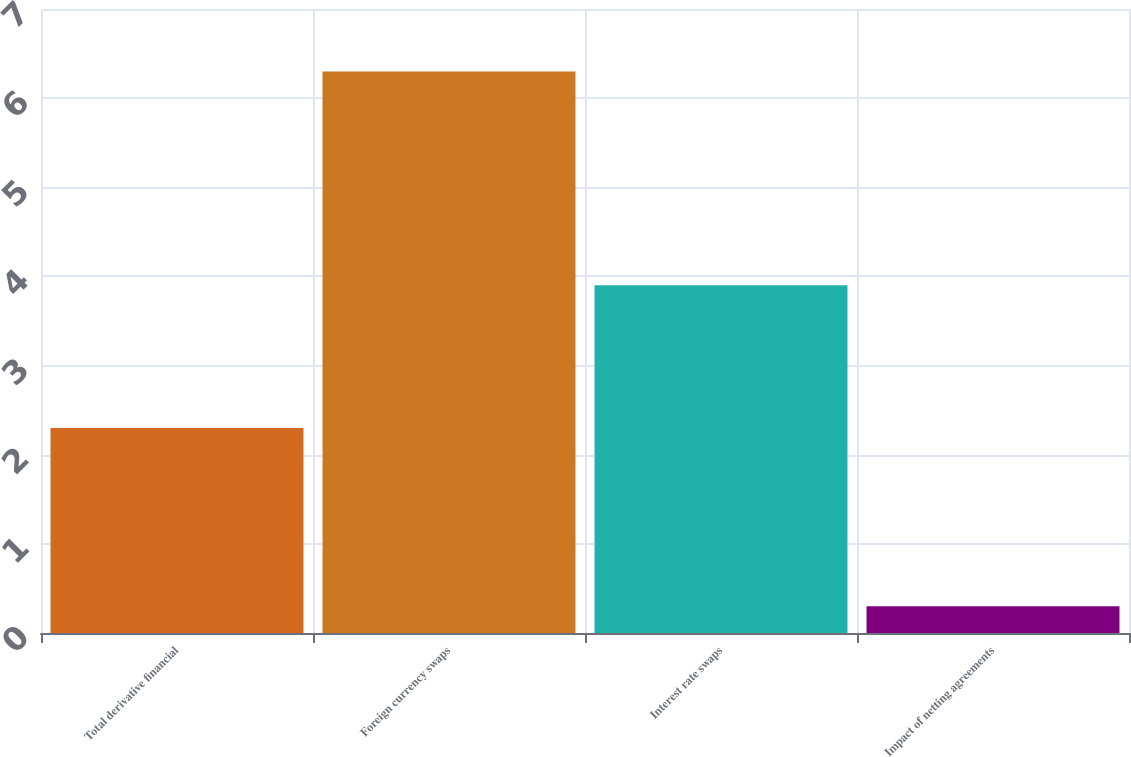<chart> <loc_0><loc_0><loc_500><loc_500><bar_chart><fcel>Total derivative financial<fcel>Foreign currency swaps<fcel>Interest rate swaps<fcel>Impact of netting agreements<nl><fcel>2.3<fcel>6.3<fcel>3.9<fcel>0.3<nl></chart> 